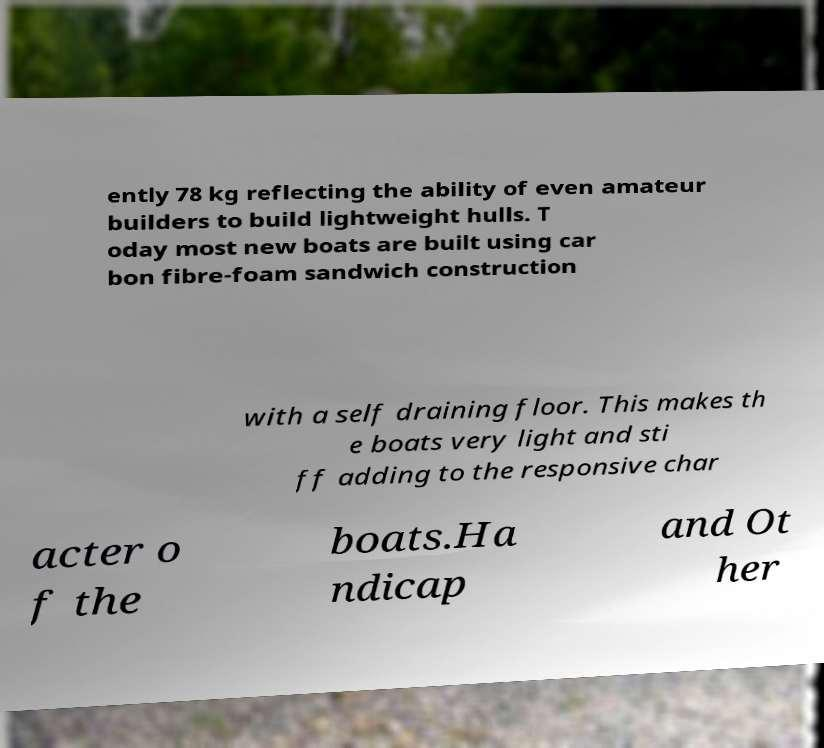There's text embedded in this image that I need extracted. Can you transcribe it verbatim? ently 78 kg reflecting the ability of even amateur builders to build lightweight hulls. T oday most new boats are built using car bon fibre-foam sandwich construction with a self draining floor. This makes th e boats very light and sti ff adding to the responsive char acter o f the boats.Ha ndicap and Ot her 